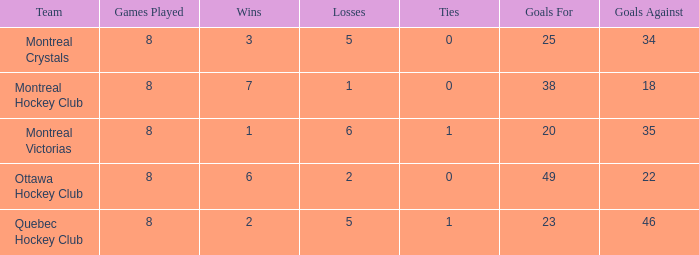What is the highest goals against when the wins is less than 1? None. 